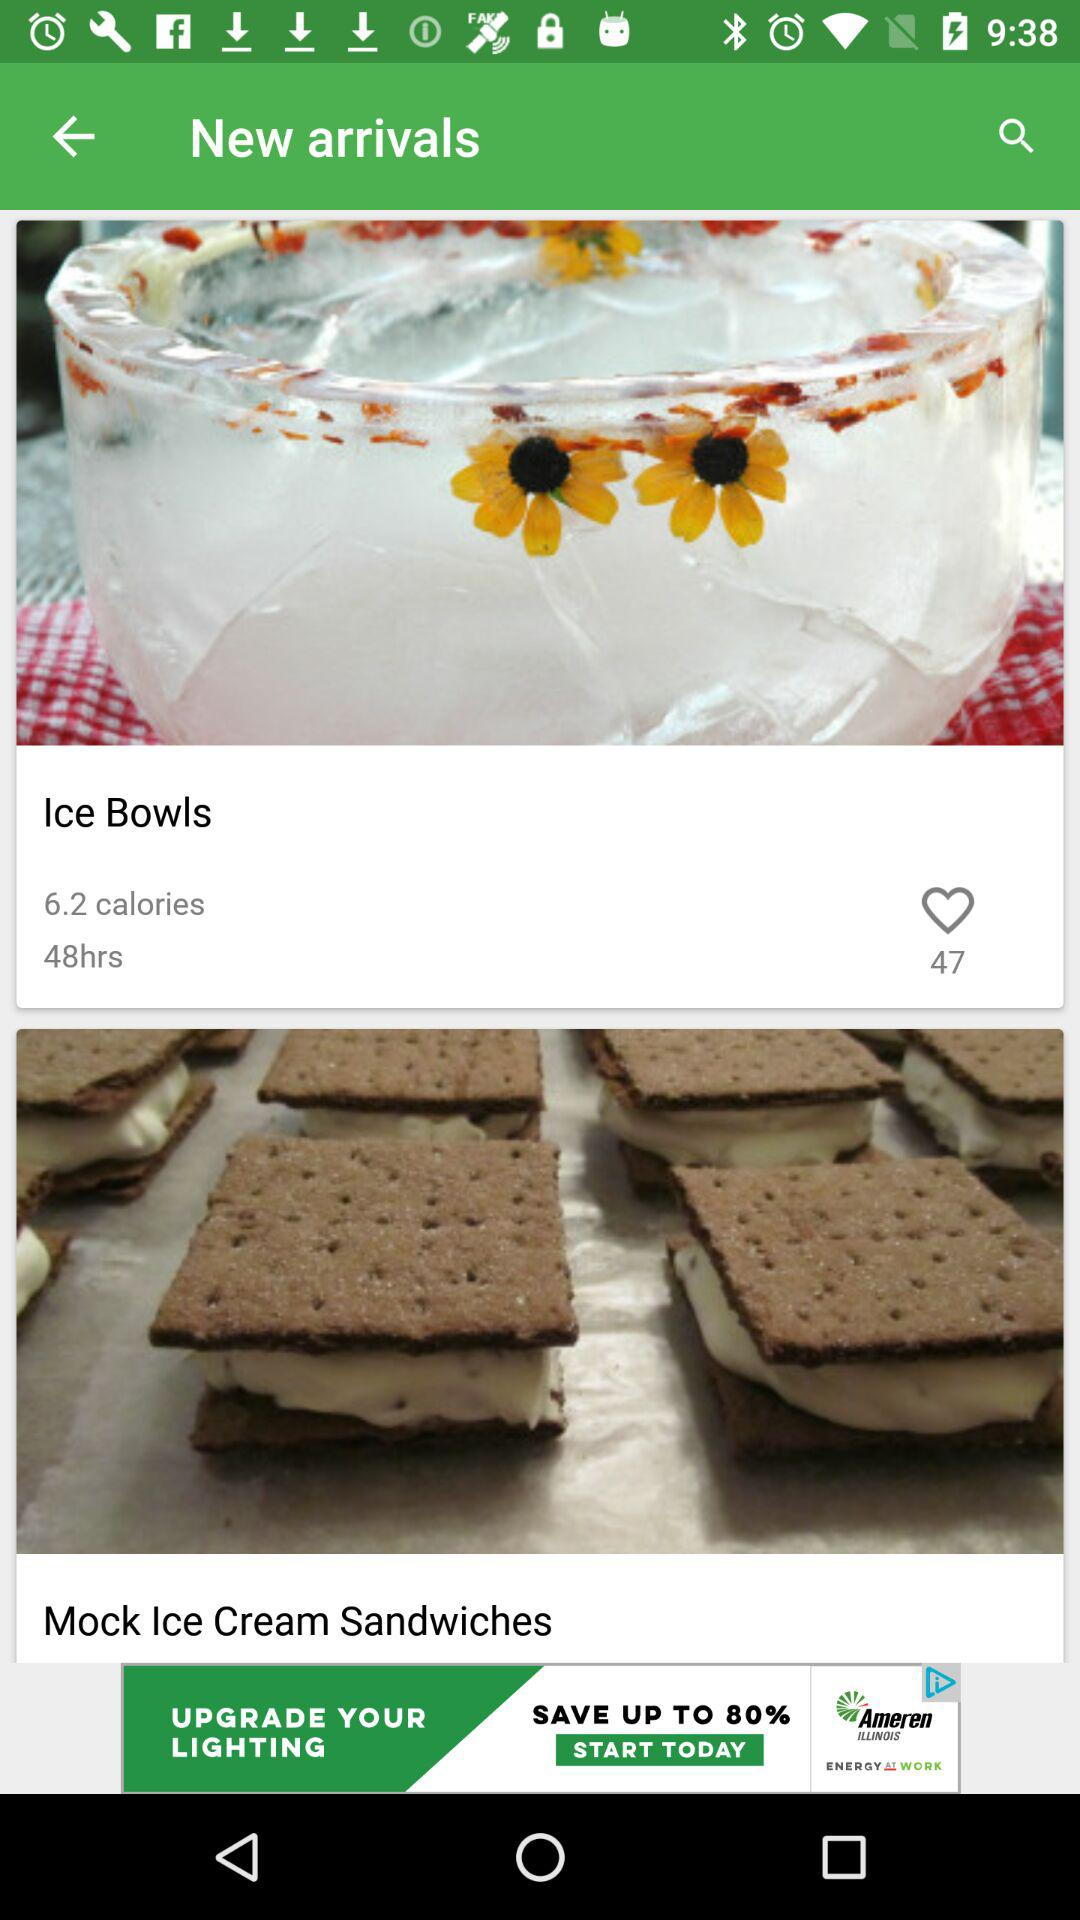How many calories do "Ice Bowls" have? "Ice Bowls" have 6.2 calories. 